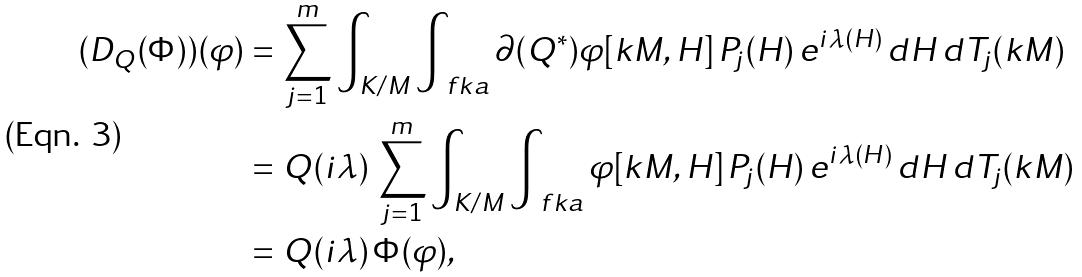<formula> <loc_0><loc_0><loc_500><loc_500>( D _ { Q } ( \Phi ) ) ( \varphi ) & = \sum _ { j = 1 } ^ { m } \int _ { K / M } \int _ { \ f k a } \partial ( Q ^ { * } ) \varphi [ k M , H ] \, P _ { j } ( H ) \, e ^ { i \lambda ( H ) } \, d H \, d T _ { j } ( k M ) \\ & = Q ( i \lambda ) \, \sum _ { j = 1 } ^ { m } \int _ { K / M } \int _ { \ f k a } \varphi [ k M , H ] \, P _ { j } ( H ) \, e ^ { i \lambda ( H ) } \, d H \, d T _ { j } ( k M ) \\ & = Q ( i \lambda ) \, \Phi ( \varphi ) ,</formula> 